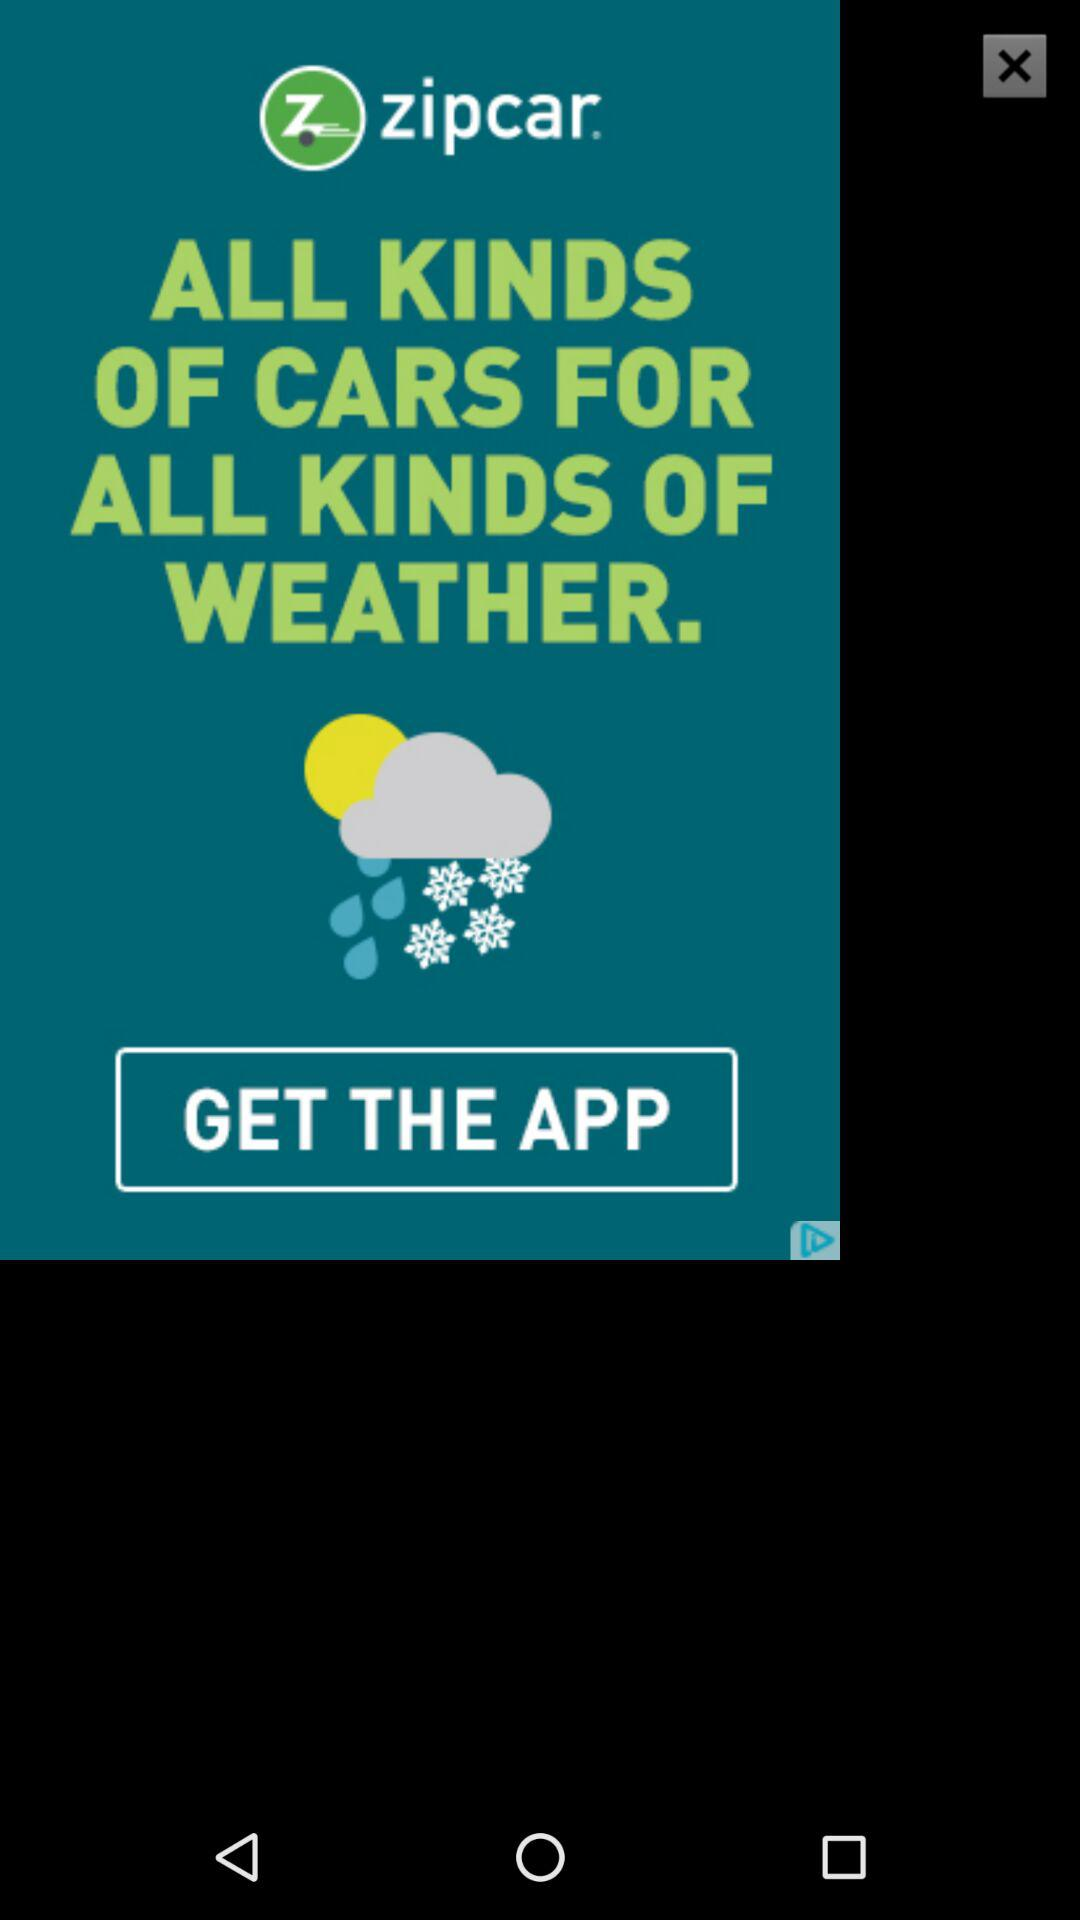What is the application name? The application name is "zipcar". 